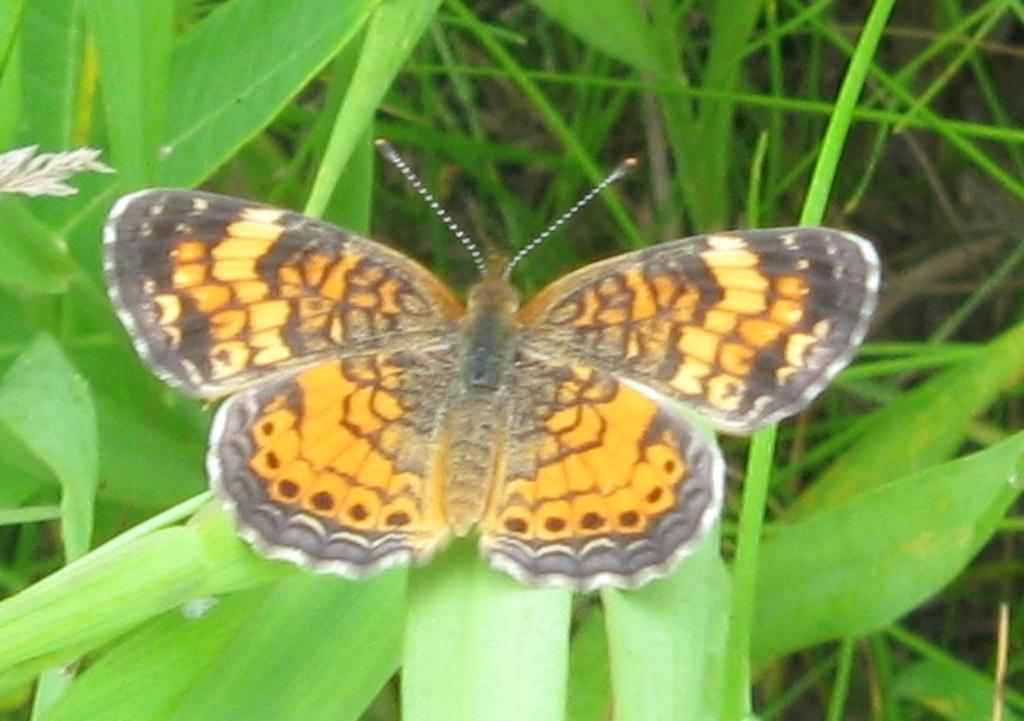What is the main subject of the image? There is a butterfly in the image. Where is the butterfly located? The butterfly is on the leaves. What can be seen in the background of the image? There is grass visible in the background of the image. How many eggs are being smashed by the butterfly in the image? There are no eggs present in the image, and the butterfly is not smashing anything. 